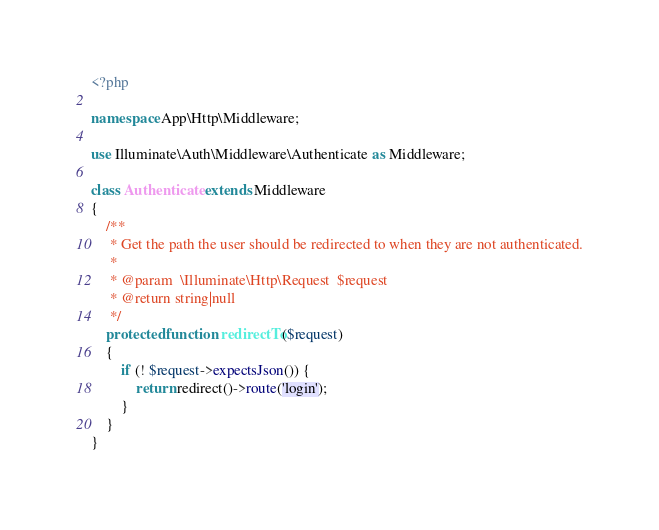<code> <loc_0><loc_0><loc_500><loc_500><_PHP_><?php

namespace App\Http\Middleware;

use Illuminate\Auth\Middleware\Authenticate as Middleware;

class Authenticate extends Middleware
{
    /**
     * Get the path the user should be redirected to when they are not authenticated.
     *
     * @param  \Illuminate\Http\Request  $request
     * @return string|null
     */
    protected function redirectTo($request)
    {
        if (! $request->expectsJson()) {
            return redirect()->route('login');
        }
    }
}
</code> 